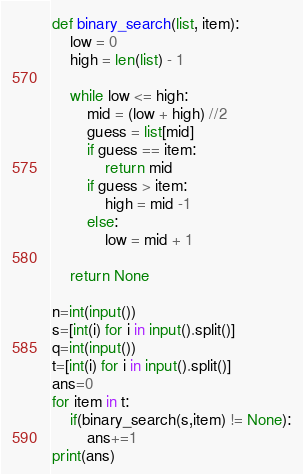Convert code to text. <code><loc_0><loc_0><loc_500><loc_500><_Python_>def binary_search(list, item):
    low = 0
    high = len(list) - 1

    while low <= high:
        mid = (low + high) //2
        guess = list[mid]
        if guess == item:
            return mid
        if guess > item:
            high = mid -1
        else:
            low = mid + 1

    return None

n=int(input())
s=[int(i) for i in input().split()]
q=int(input())
t=[int(i) for i in input().split()]
ans=0
for item in t:
    if(binary_search(s,item) != None):
        ans+=1
print(ans)
</code> 